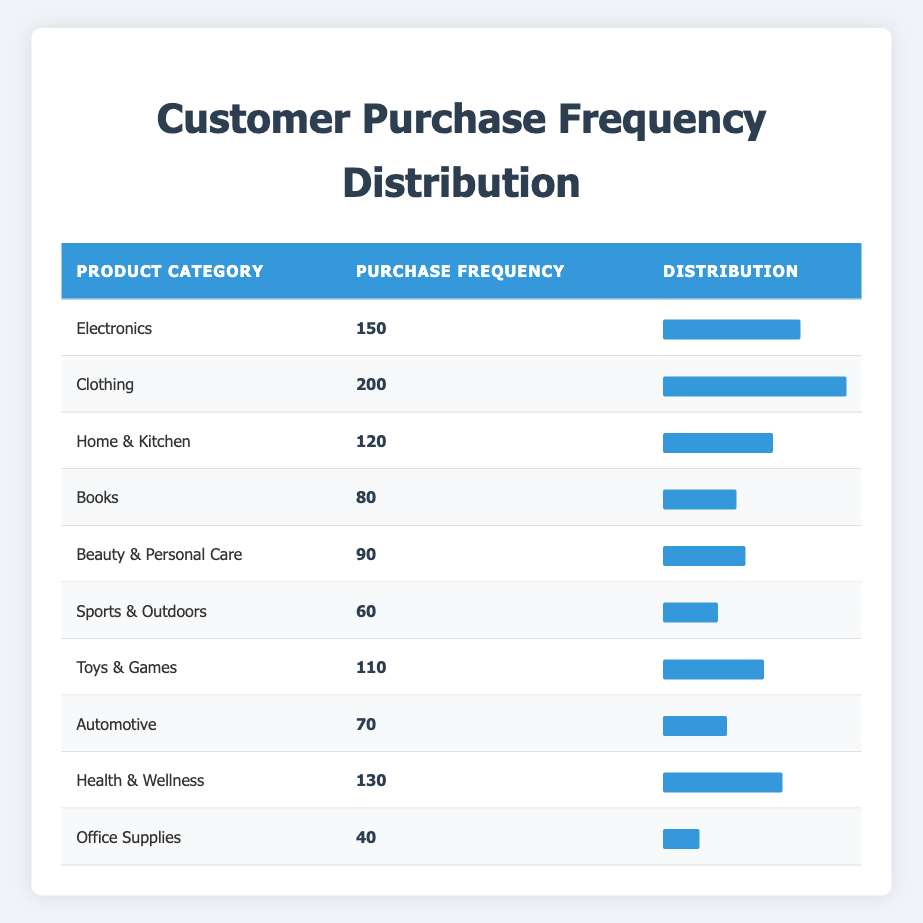What is the product category with the highest purchase frequency? The table lists various product categories along with their purchase frequencies. By identifying the category with the highest number, we can see that "Clothing" has a purchase frequency of 200, which is the largest among all categories.
Answer: Clothing What is the purchase frequency of the "Books" category? The table displays the purchase frequency for each product category. In the case of "Books", the purchase frequency is explicitly noted as 80.
Answer: 80 Which product category has a purchase frequency of 90? Looking at the table, the category "Beauty & Personal Care" is listed with a purchase frequency of 90.
Answer: Beauty & Personal Care What is the total purchase frequency for "Electronics", "Health & Wellness", and "Home & Kitchen"? To get this total, we need to sum the purchase frequencies for the specified categories: Electronics (150) + Health & Wellness (130) + Home & Kitchen (120) = 400.
Answer: 400 Is "Sports & Outdoors" the product category with the lowest purchase frequency? By examining the table, the category "Sports & Outdoors" has a purchase frequency of 60, which is correct. However, "Office Supplies" has a lower frequency of 40, thus making "Sports & Outdoors" not the lowest.
Answer: No Calculate the average purchase frequency of the product categories listed in the table. First, we sum the purchase frequencies of all categories: 150 + 200 + 120 + 80 + 90 + 60 + 110 + 70 + 130 + 40 = 1050. There are 10 categories, so the average frequency is 1050 / 10 = 105.
Answer: 105 Which category has a purchase frequency that is twice as low as "Clothing"? The category "Clothing" has a purchase frequency of 200. Half of that is 100; thus, we need to find a category with a frequency of 100. "Health & Wellness" is 130 and "Electronics" is 150, but "Toys & Games" has a frequency of 110, which is still higher. The available lowest category with value nearest would be "Beauty & Personal Care" at 90, but it's not twice as low. Thus, there is no category that meets the specified criteria.
Answer: None What is the range of purchase frequencies across all product categories? The table shows the highest purchase frequency is for "Clothing" at 200 and the lowest is "Office Supplies" at 40. The range is calculated as the highest frequency (200) minus the lowest frequency (40), which results in 160.
Answer: 160 